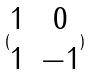Convert formula to latex. <formula><loc_0><loc_0><loc_500><loc_500>( \begin{matrix} 1 & 0 \\ 1 & - 1 \end{matrix} )</formula> 